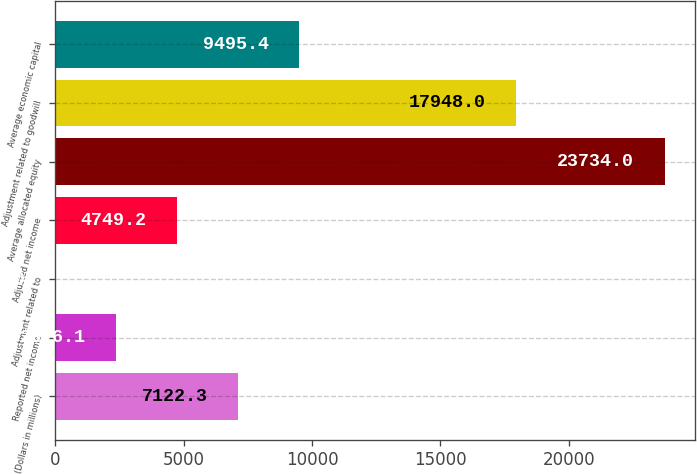Convert chart to OTSL. <chart><loc_0><loc_0><loc_500><loc_500><bar_chart><fcel>(Dollars in millions)<fcel>Reported net income<fcel>Adjustment related to<fcel>Adjusted net income<fcel>Average allocated equity<fcel>Adjustment related to goodwill<fcel>Average economic capital<nl><fcel>7122.3<fcel>2376.1<fcel>3<fcel>4749.2<fcel>23734<fcel>17948<fcel>9495.4<nl></chart> 